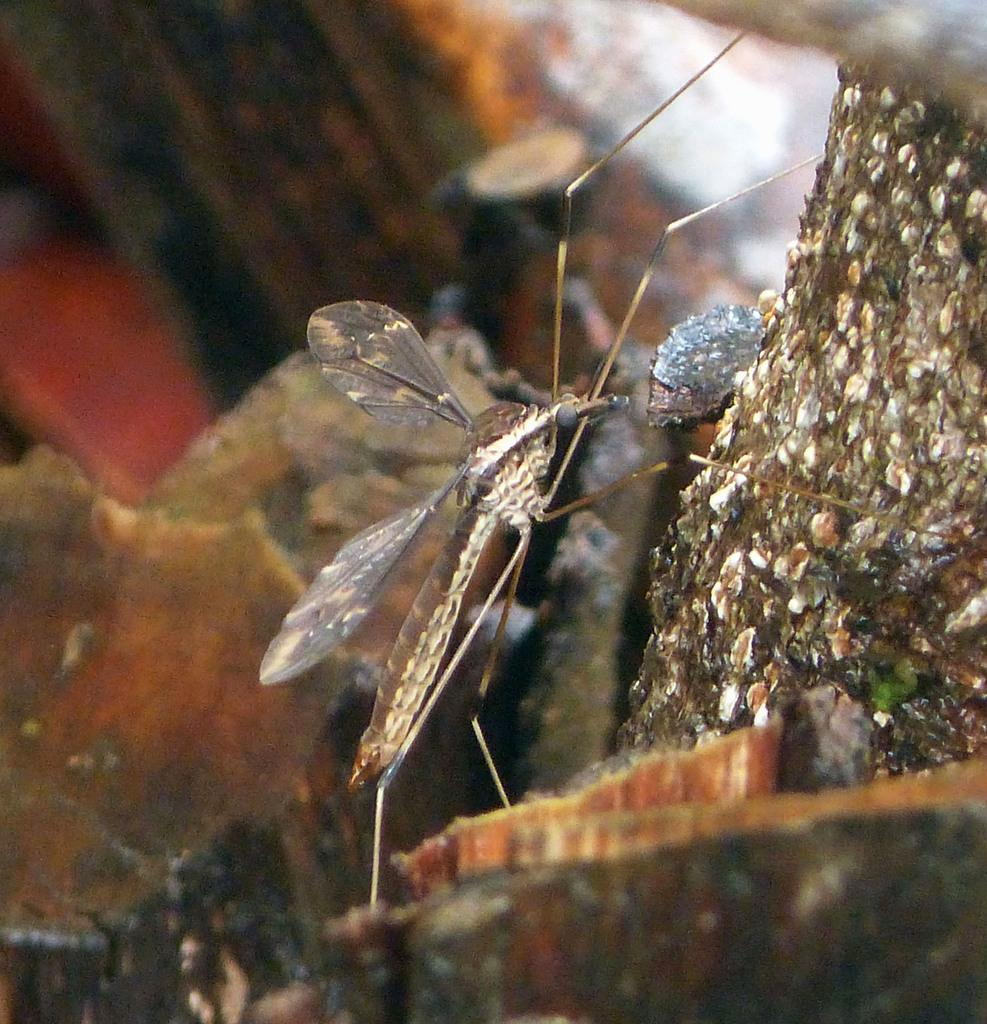What type of creature is in the image? There is an insect in the image. What colors can be seen on the insect? The insect has black, brown, and cream colors. What is the background or surface in the image? The insect is on a colorful surface. What type of pencil is the insect using to write in the image? There is no pencil present in the image, and insects do not use pencils to write. 